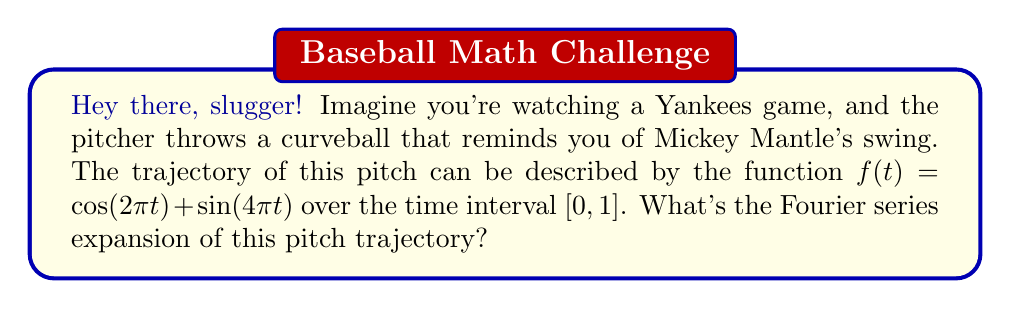Show me your answer to this math problem. Alright, let's break this down like a jazz rhythm:

1) The given function $f(t) = \cos(2\pi t) + \sin(4\pi t)$ is already in a form similar to a Fourier series. We just need to identify the coefficients.

2) The general form of a Fourier series is:

   $$f(t) = \frac{a_0}{2} + \sum_{n=1}^{\infty} (a_n \cos(2\pi nt) + b_n \sin(2\pi nt))$$

3) Comparing our function to this general form:

   - We have a $\cos(2\pi t)$ term, which corresponds to $n=1$ in the cosine part.
   - We have a $\sin(4\pi t)$ term, which corresponds to $n=2$ in the sine part.

4) Identifying the coefficients:

   - $a_0 = 0$ (no constant term)
   - $a_1 = 1$ (coefficient of $\cos(2\pi t)$)
   - $b_2 = 1$ (coefficient of $\sin(4\pi t)$)
   - All other coefficients are zero

5) Therefore, our Fourier series expansion is:

   $$f(t) = \cos(2\pi t) + \sin(4\pi t)$$

This is already in its simplest form, as compact as Mickey Mantle's powerful swing!
Answer: $$f(t) = \cos(2\pi t) + \sin(4\pi t)$$ 